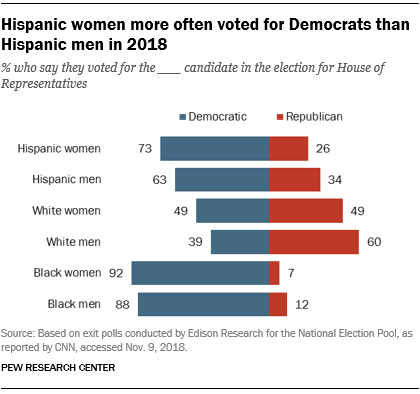Identify some key points in this picture. The total value of Democratic Hispanic women and Hispanic men is 136. 